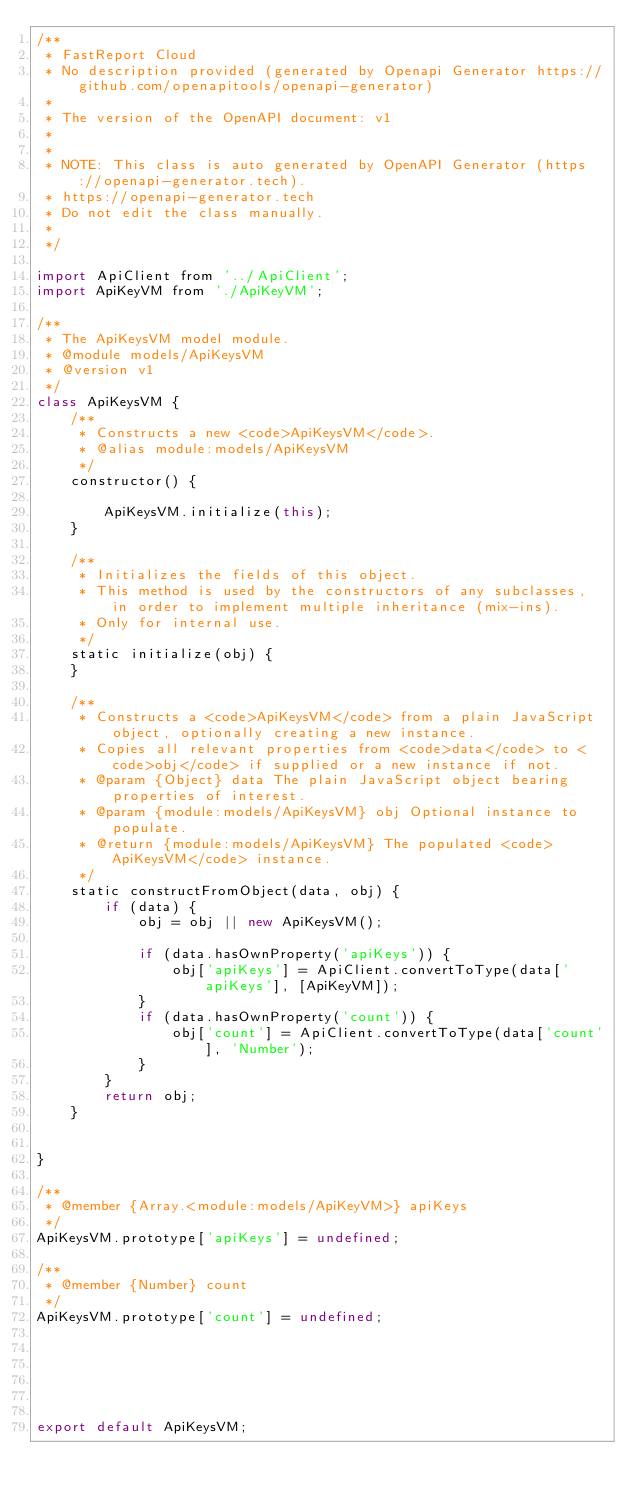Convert code to text. <code><loc_0><loc_0><loc_500><loc_500><_JavaScript_>/**
 * FastReport Cloud
 * No description provided (generated by Openapi Generator https://github.com/openapitools/openapi-generator)
 *
 * The version of the OpenAPI document: v1
 * 
 *
 * NOTE: This class is auto generated by OpenAPI Generator (https://openapi-generator.tech).
 * https://openapi-generator.tech
 * Do not edit the class manually.
 *
 */

import ApiClient from '../ApiClient';
import ApiKeyVM from './ApiKeyVM';

/**
 * The ApiKeysVM model module.
 * @module models/ApiKeysVM
 * @version v1
 */
class ApiKeysVM {
    /**
     * Constructs a new <code>ApiKeysVM</code>.
     * @alias module:models/ApiKeysVM
     */
    constructor() { 
        
        ApiKeysVM.initialize(this);
    }

    /**
     * Initializes the fields of this object.
     * This method is used by the constructors of any subclasses, in order to implement multiple inheritance (mix-ins).
     * Only for internal use.
     */
    static initialize(obj) { 
    }

    /**
     * Constructs a <code>ApiKeysVM</code> from a plain JavaScript object, optionally creating a new instance.
     * Copies all relevant properties from <code>data</code> to <code>obj</code> if supplied or a new instance if not.
     * @param {Object} data The plain JavaScript object bearing properties of interest.
     * @param {module:models/ApiKeysVM} obj Optional instance to populate.
     * @return {module:models/ApiKeysVM} The populated <code>ApiKeysVM</code> instance.
     */
    static constructFromObject(data, obj) {
        if (data) {
            obj = obj || new ApiKeysVM();

            if (data.hasOwnProperty('apiKeys')) {
                obj['apiKeys'] = ApiClient.convertToType(data['apiKeys'], [ApiKeyVM]);
            }
            if (data.hasOwnProperty('count')) {
                obj['count'] = ApiClient.convertToType(data['count'], 'Number');
            }
        }
        return obj;
    }


}

/**
 * @member {Array.<module:models/ApiKeyVM>} apiKeys
 */
ApiKeysVM.prototype['apiKeys'] = undefined;

/**
 * @member {Number} count
 */
ApiKeysVM.prototype['count'] = undefined;






export default ApiKeysVM;

</code> 